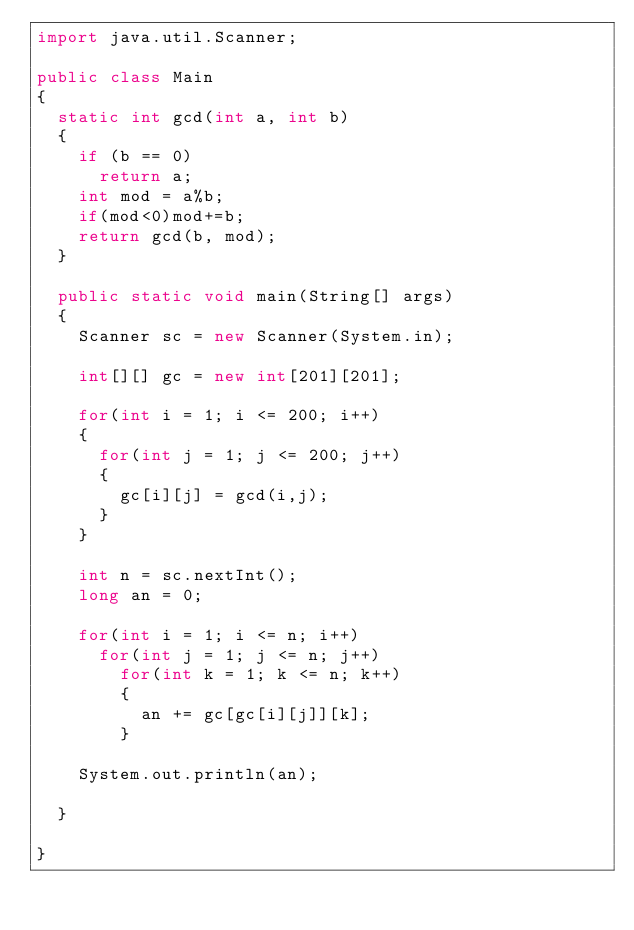Convert code to text. <code><loc_0><loc_0><loc_500><loc_500><_Java_>import java.util.Scanner;

public class Main 
{
	static int gcd(int a, int b)
	{
		if (b == 0) 
			return a; 
		int mod = a%b;
		if(mod<0)mod+=b;
		return gcd(b, mod);
	}

	public static void main(String[] args) 
	{
		Scanner sc = new Scanner(System.in);
		
		int[][] gc = new int[201][201];
		
		for(int i = 1; i <= 200; i++)
		{
			for(int j = 1; j <= 200; j++)
			{
				gc[i][j] = gcd(i,j);
			}
		}
		
		int n = sc.nextInt();
		long an = 0;
		
		for(int i = 1; i <= n; i++)
			for(int j = 1; j <= n; j++)
				for(int k = 1; k <= n; k++)
				{
					an += gc[gc[i][j]][k];
				}
		
		System.out.println(an);
		
	}

}
</code> 